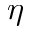<formula> <loc_0><loc_0><loc_500><loc_500>\eta</formula> 